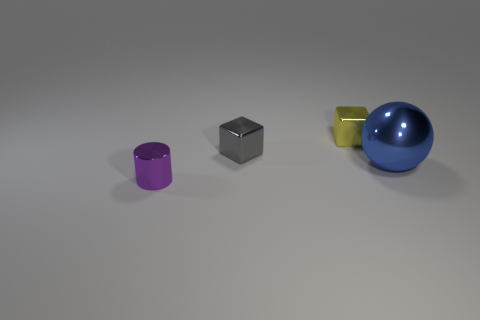Subtract all gray cubes. How many cubes are left? 1 Subtract 1 spheres. How many spheres are left? 0 Subtract all blue cylinders. How many red spheres are left? 0 Add 4 gray things. How many objects exist? 8 Subtract all brown balls. Subtract all brown cubes. How many balls are left? 1 Subtract all big shiny spheres. Subtract all blue objects. How many objects are left? 2 Add 3 balls. How many balls are left? 4 Add 3 big purple metal things. How many big purple metal things exist? 3 Subtract 0 purple balls. How many objects are left? 4 